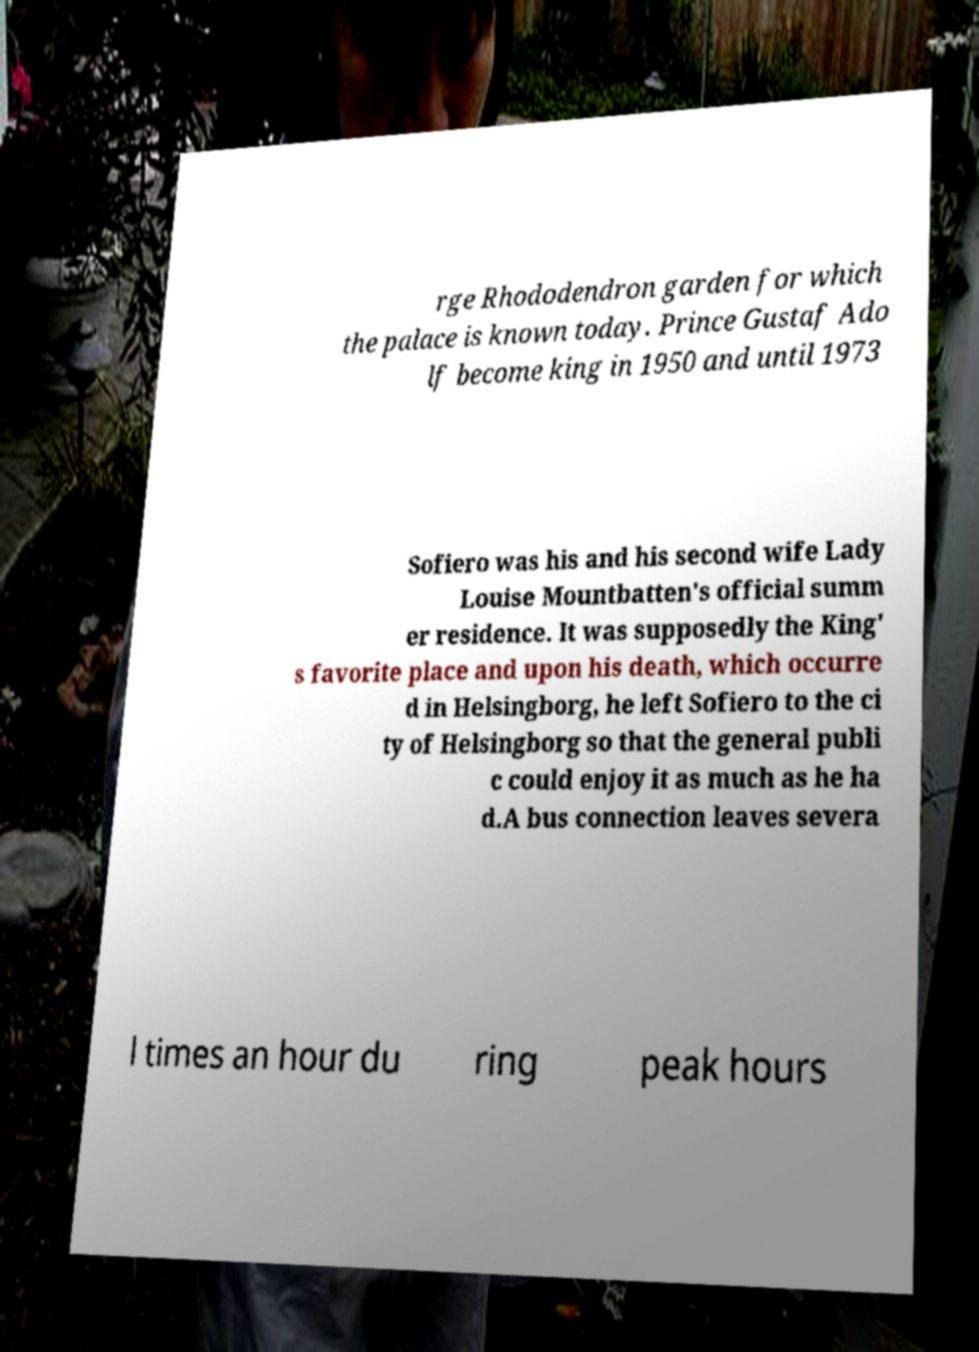Can you read and provide the text displayed in the image?This photo seems to have some interesting text. Can you extract and type it out for me? rge Rhododendron garden for which the palace is known today. Prince Gustaf Ado lf become king in 1950 and until 1973 Sofiero was his and his second wife Lady Louise Mountbatten's official summ er residence. It was supposedly the King' s favorite place and upon his death, which occurre d in Helsingborg, he left Sofiero to the ci ty of Helsingborg so that the general publi c could enjoy it as much as he ha d.A bus connection leaves severa l times an hour du ring peak hours 